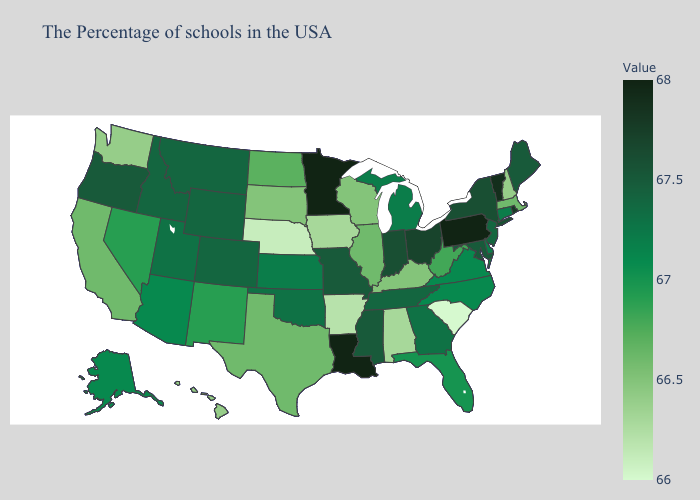Among the states that border Colorado , which have the lowest value?
Keep it brief. Nebraska. Does New Hampshire have the lowest value in the Northeast?
Answer briefly. Yes. Among the states that border Vermont , does New Hampshire have the lowest value?
Keep it brief. Yes. Does the map have missing data?
Short answer required. No. Does the map have missing data?
Quick response, please. No. Among the states that border Arkansas , which have the lowest value?
Write a very short answer. Texas. 